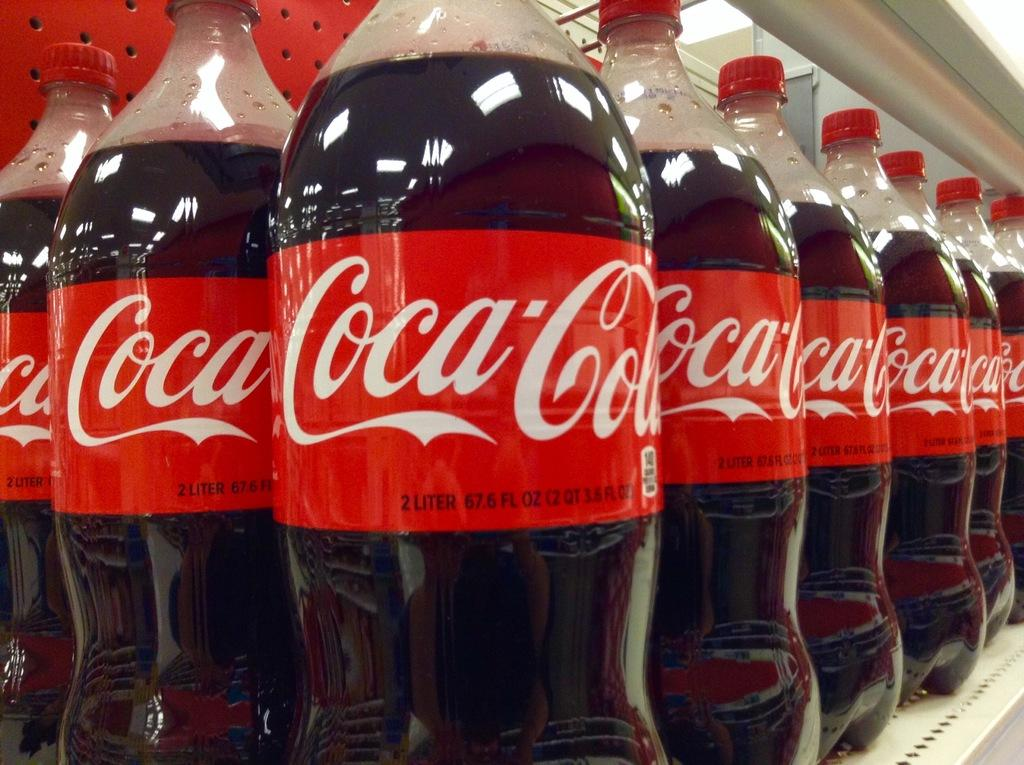What type of objects can be seen in the image? There are bottles in the image. What colors are the bottles? The bottles are black and red in color. What brand name is written on the bottles? The word "COCA-COLA" is written on the bottles. Are there any other words written on the bottles besides the brand name? Yes, there are other words written on the bottles. What type of curtain is hanging in the background of the image? There is no curtain present in the image; it only features bottles. Can you tell me how many chickens are visible in the image? There are no chickens present in the image; it only features bottles. 